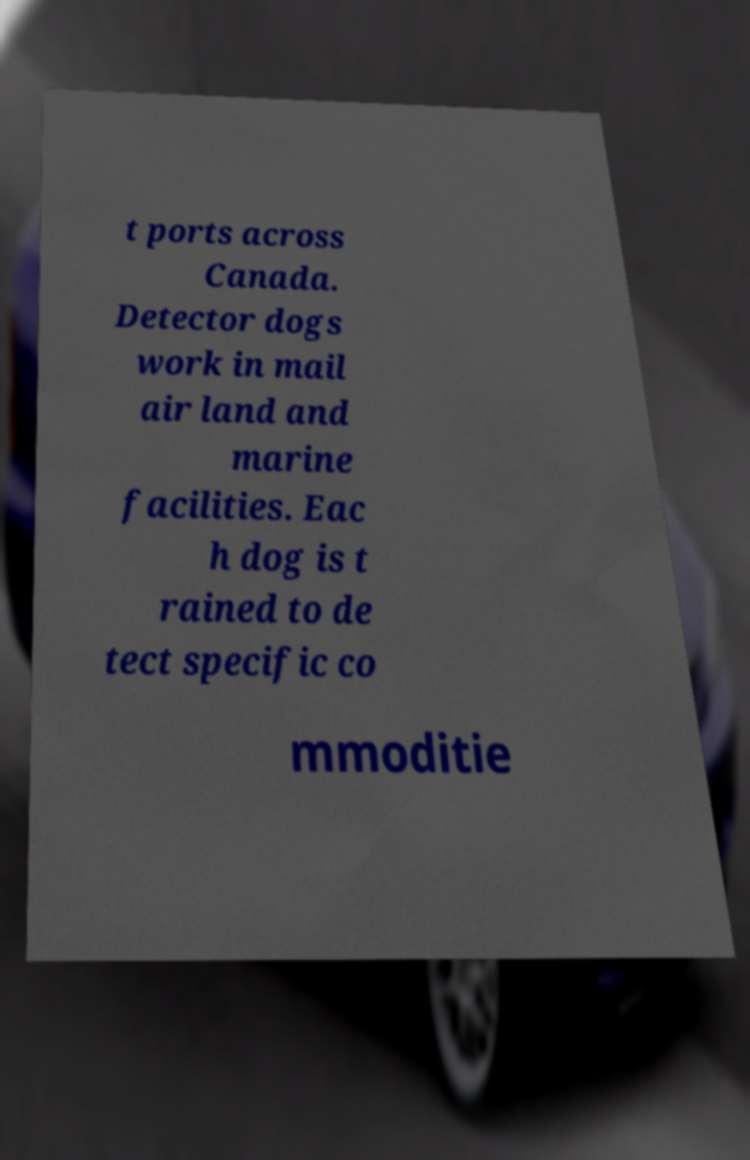Please read and relay the text visible in this image. What does it say? t ports across Canada. Detector dogs work in mail air land and marine facilities. Eac h dog is t rained to de tect specific co mmoditie 